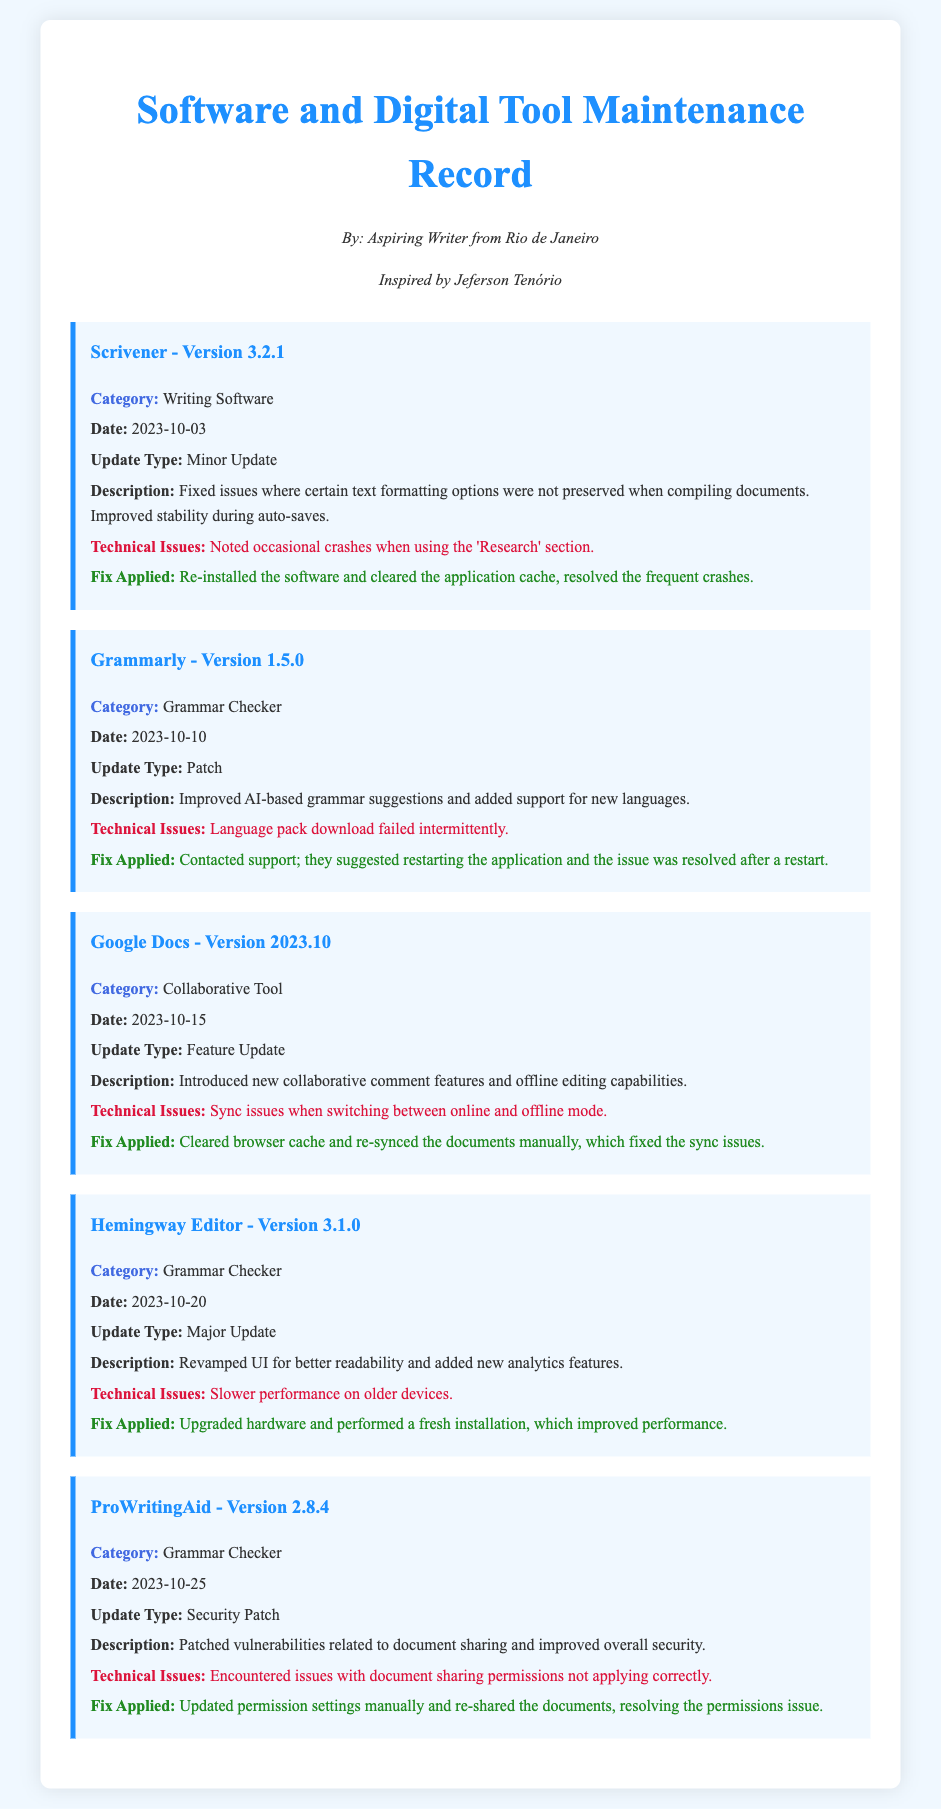What is the latest version of Scrivener? The document lists Scrivener with version 3.2.1.
Answer: 3.2.1 What was a technical issue encountered in Grammarly? The document states that the technical issue in Grammarly was the language pack download failing intermittently.
Answer: Language pack download failed intermittently What date was the fix applied for Google Docs? The fix for Google Docs was applied on 2023-10-15.
Answer: 2023-10-15 Which grammar checker had a major update? The document indicates that the Hemingway Editor had a major update.
Answer: Hemingway Editor What was improved in ProWritingAid's latest update? The document describes that ProWritingAid patched vulnerabilities related to document sharing.
Answer: Patched vulnerabilities related to document sharing 